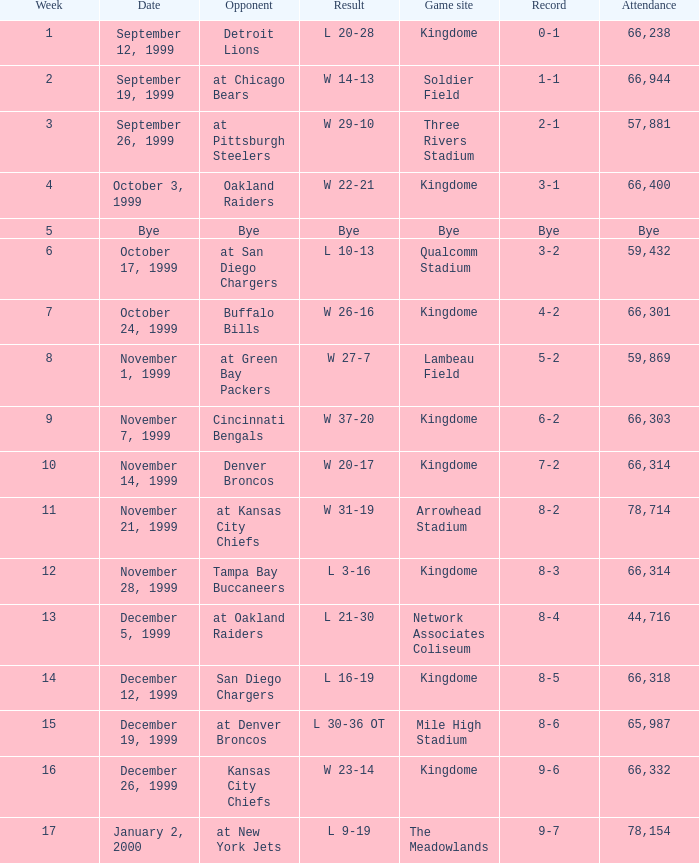What is the record for the game played during the second week? 1-1. 